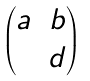Convert formula to latex. <formula><loc_0><loc_0><loc_500><loc_500>\begin{pmatrix} a & b \\ & d \end{pmatrix}</formula> 